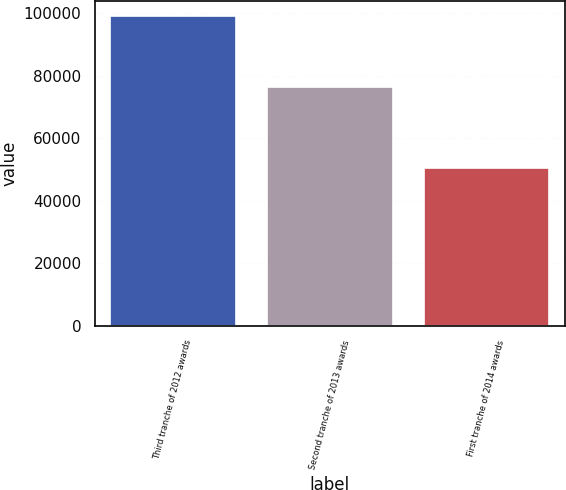Convert chart to OTSL. <chart><loc_0><loc_0><loc_500><loc_500><bar_chart><fcel>Third tranche of 2012 awards<fcel>Second tranche of 2013 awards<fcel>First tranche of 2014 awards<nl><fcel>99023<fcel>76232<fcel>50574<nl></chart> 